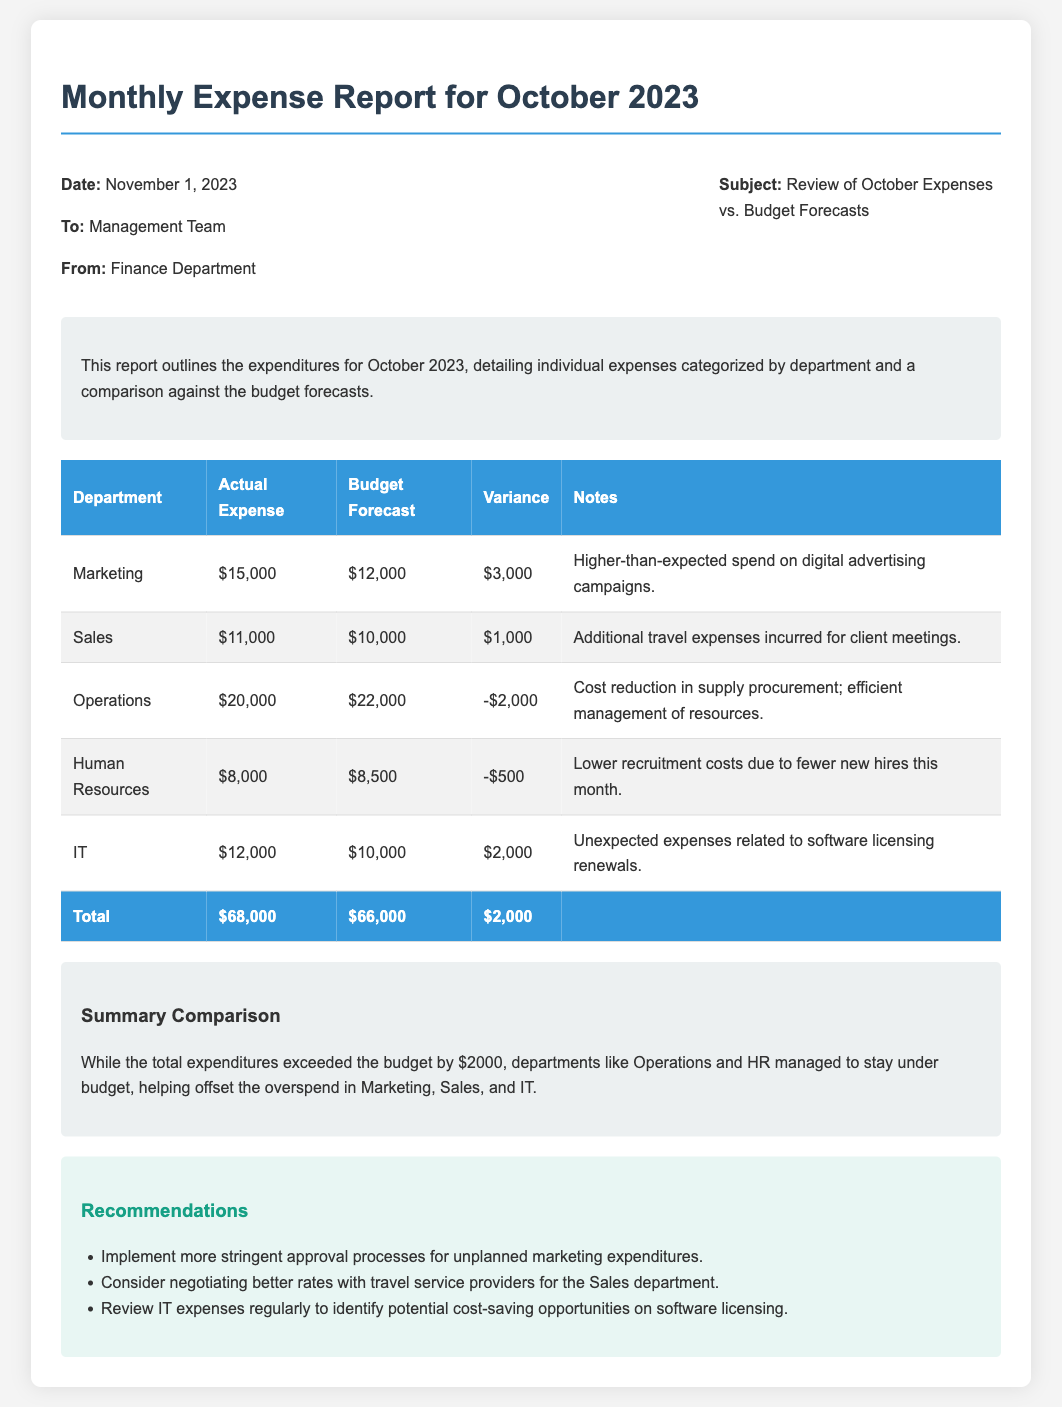What is the date of the report? The date mentioned in the report is stated in the header information section.
Answer: November 1, 2023 Who is the report addressed to? The "To" section of the header indicates who the report is directed to.
Answer: Management Team What is the actual expense for the Marketing department? The actual expense for Marketing is listed in the table under the actual expenses column.
Answer: $15,000 What was the budget forecast for the IT department? The budget forecast for IT can be found in the budget forecast column of the table.
Answer: $10,000 What is the total variance across all departments? The total variance can be calculated based on the summary provided in the table footer.
Answer: $2,000 Which department had higher-than-expected spending? The notes column specifies which department had overspending in the report.
Answer: Marketing What recommendation is made regarding marketing expenditures? The recommendations section outlines specific advice for managing budget expenditures.
Answer: Implement more stringent approval processes for unplanned marketing expenditures Which department managed to stay under budget? The notes section provides information about departments that remained within budget constraints.
Answer: Operations What was the actual expense for the Human Resources department? The actual expense for Human Resources is recorded in the table.
Answer: $8,000 